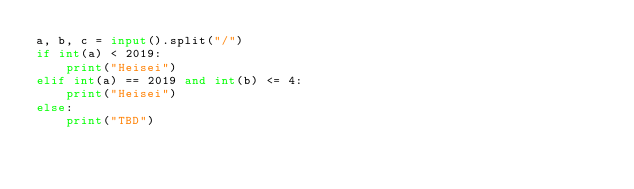Convert code to text. <code><loc_0><loc_0><loc_500><loc_500><_Python_>a, b, c = input().split("/")
if int(a) < 2019:
    print("Heisei")
elif int(a) == 2019 and int(b) <= 4:
    print("Heisei")
else:
    print("TBD")</code> 